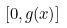<formula> <loc_0><loc_0><loc_500><loc_500>[ 0 , g ( x ) ]</formula> 